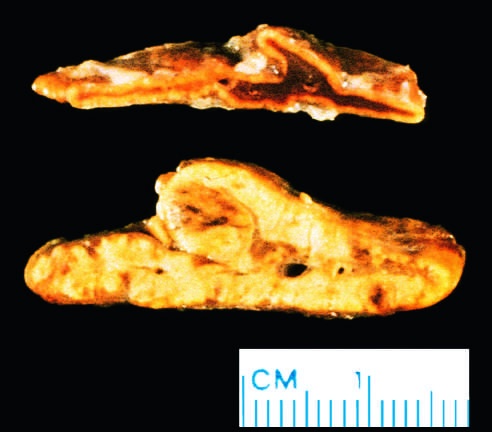s diffuse hyperplasia of the adrenal gland contrasted with a normal adrenal gland?
Answer the question using a single word or phrase. Yes 